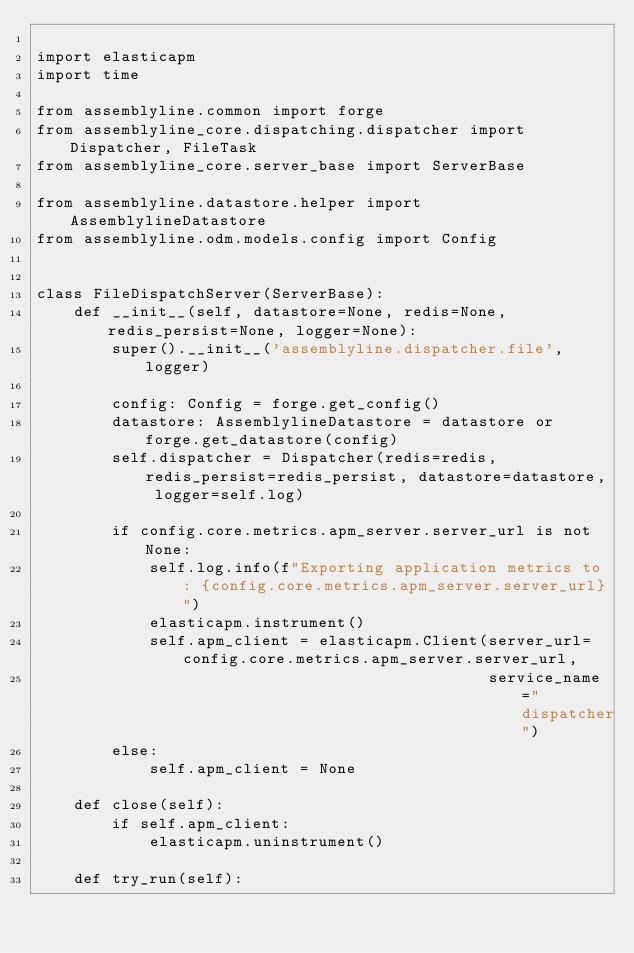Convert code to text. <code><loc_0><loc_0><loc_500><loc_500><_Python_>
import elasticapm
import time

from assemblyline.common import forge
from assemblyline_core.dispatching.dispatcher import Dispatcher, FileTask
from assemblyline_core.server_base import ServerBase

from assemblyline.datastore.helper import AssemblylineDatastore
from assemblyline.odm.models.config import Config


class FileDispatchServer(ServerBase):
    def __init__(self, datastore=None, redis=None, redis_persist=None, logger=None):
        super().__init__('assemblyline.dispatcher.file', logger)
        
        config: Config = forge.get_config()
        datastore: AssemblylineDatastore = datastore or forge.get_datastore(config)
        self.dispatcher = Dispatcher(redis=redis, redis_persist=redis_persist, datastore=datastore, logger=self.log)
        
        if config.core.metrics.apm_server.server_url is not None:
            self.log.info(f"Exporting application metrics to: {config.core.metrics.apm_server.server_url}")
            elasticapm.instrument()
            self.apm_client = elasticapm.Client(server_url=config.core.metrics.apm_server.server_url,
                                                service_name="dispatcher")
        else:
            self.apm_client = None
            
    def close(self):
        if self.apm_client:
            elasticapm.uninstrument()

    def try_run(self):</code> 